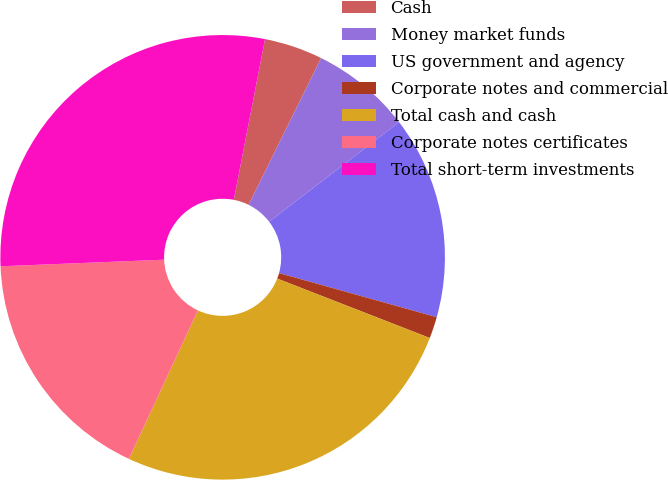Convert chart. <chart><loc_0><loc_0><loc_500><loc_500><pie_chart><fcel>Cash<fcel>Money market funds<fcel>US government and agency<fcel>Corporate notes and commercial<fcel>Total cash and cash<fcel>Corporate notes certificates<fcel>Total short-term investments<nl><fcel>4.25%<fcel>7.29%<fcel>14.75%<fcel>1.57%<fcel>26.02%<fcel>17.43%<fcel>28.7%<nl></chart> 